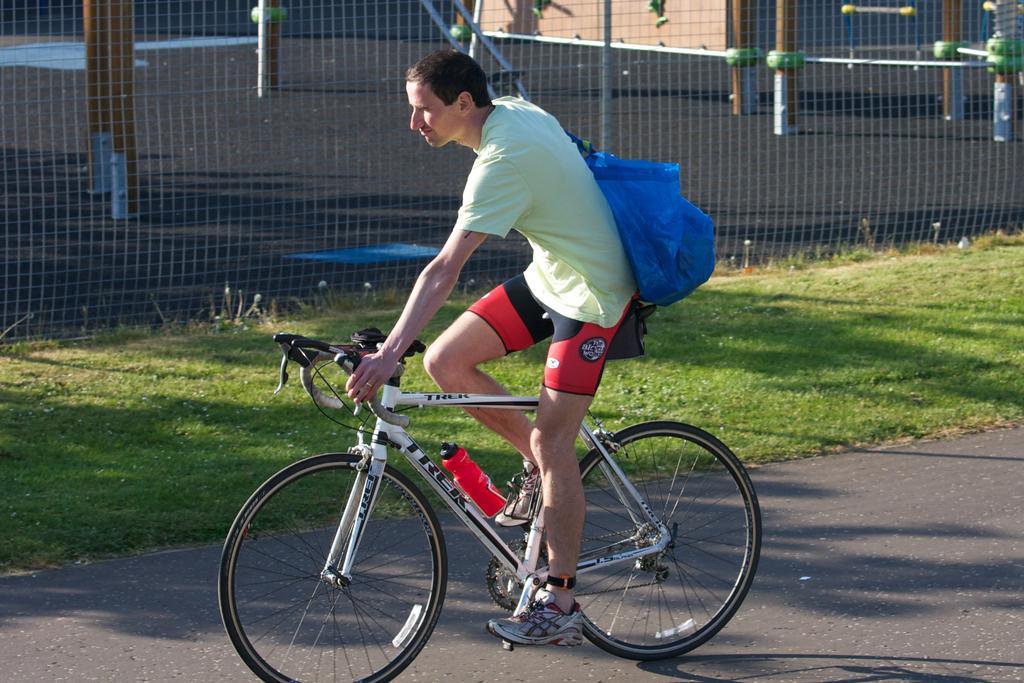Describe this image in one or two sentences. In this image I can see a person riding a bicycle and wearing a blue color bag. Back I can see a net fencing,poles and grass. 